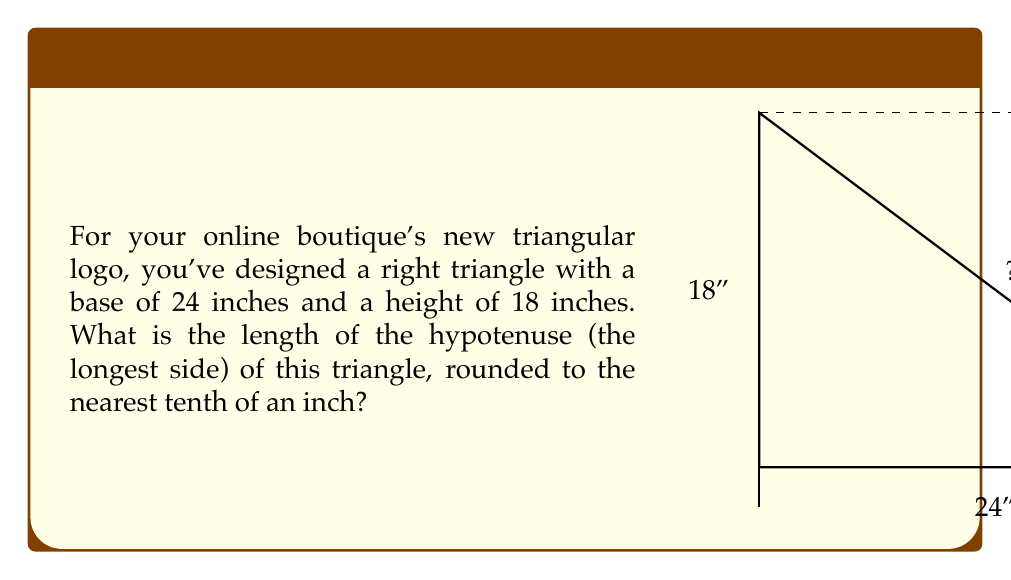Teach me how to tackle this problem. Let's approach this step-by-step using the Pythagorean theorem:

1) In a right triangle, the Pythagorean theorem states that:
   $a^2 + b^2 = c^2$
   where $c$ is the length of the hypotenuse, and $a$ and $b$ are the lengths of the other two sides.

2) We know:
   Base (a) = 24 inches
   Height (b) = 18 inches
   Hypotenuse (c) = unknown

3) Let's plug these values into the Pythagorean theorem:
   $24^2 + 18^2 = c^2$

4) Simplify the squares:
   $576 + 324 = c^2$

5) Add the left side:
   $900 = c^2$

6) To find $c$, we need to take the square root of both sides:
   $\sqrt{900} = c$

7) Simplify:
   $30 = c$

8) The question asks for the answer rounded to the nearest tenth, but 30 is already a whole number, so no rounding is necessary.

Therefore, the length of the hypotenuse is 30 inches.
Answer: 30 inches 